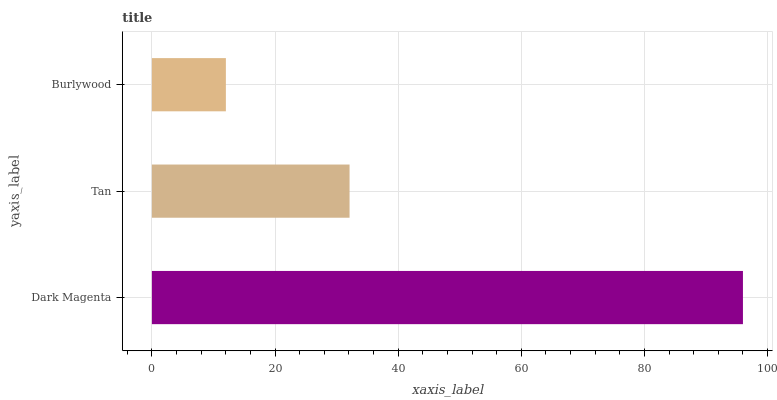Is Burlywood the minimum?
Answer yes or no. Yes. Is Dark Magenta the maximum?
Answer yes or no. Yes. Is Tan the minimum?
Answer yes or no. No. Is Tan the maximum?
Answer yes or no. No. Is Dark Magenta greater than Tan?
Answer yes or no. Yes. Is Tan less than Dark Magenta?
Answer yes or no. Yes. Is Tan greater than Dark Magenta?
Answer yes or no. No. Is Dark Magenta less than Tan?
Answer yes or no. No. Is Tan the high median?
Answer yes or no. Yes. Is Tan the low median?
Answer yes or no. Yes. Is Burlywood the high median?
Answer yes or no. No. Is Burlywood the low median?
Answer yes or no. No. 